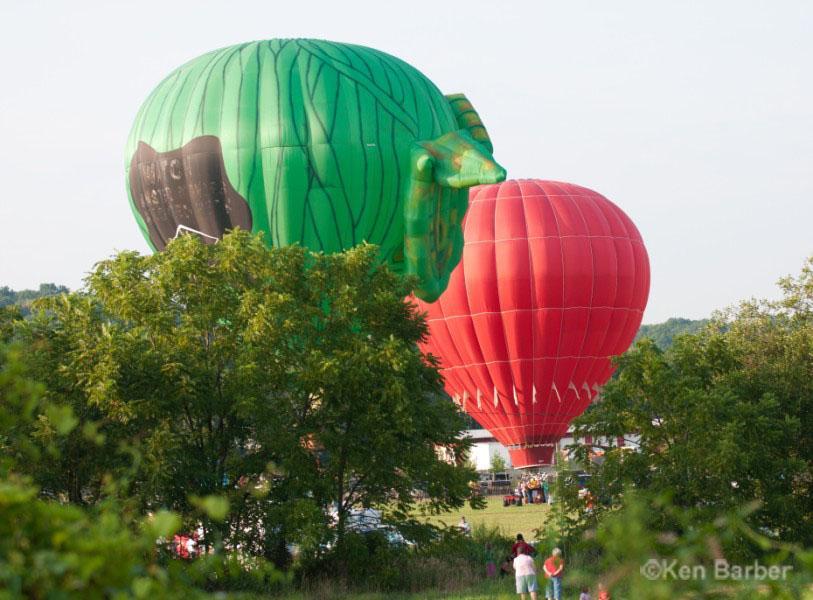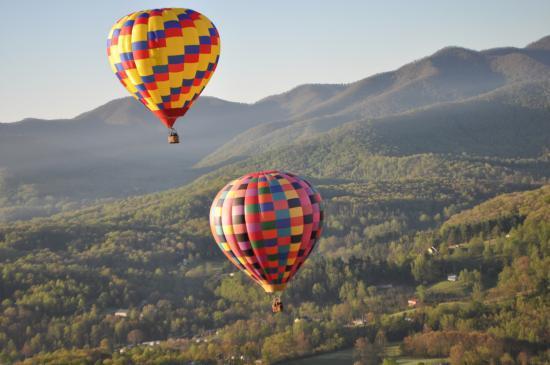The first image is the image on the left, the second image is the image on the right. Assess this claim about the two images: "There is at least one green and yellow balloon in the image on the left.". Correct or not? Answer yes or no. No. The first image is the image on the left, the second image is the image on the right. Analyze the images presented: Is the assertion "Only balloons with green-and-yellow color schemes are shown, and the image includes a balloon with a diamond shape on it." valid? Answer yes or no. No. 